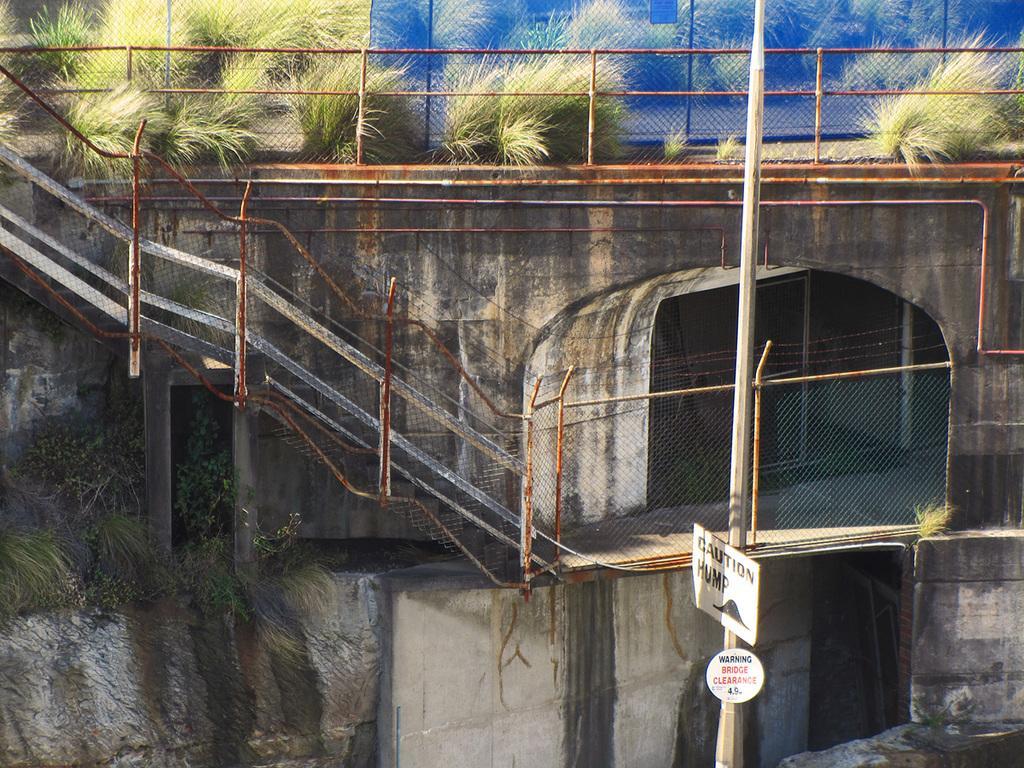Describe this image in one or two sentences. In this image I can see a pole, few boards, fencing, railings, bushes and on these words I can see something is written. 